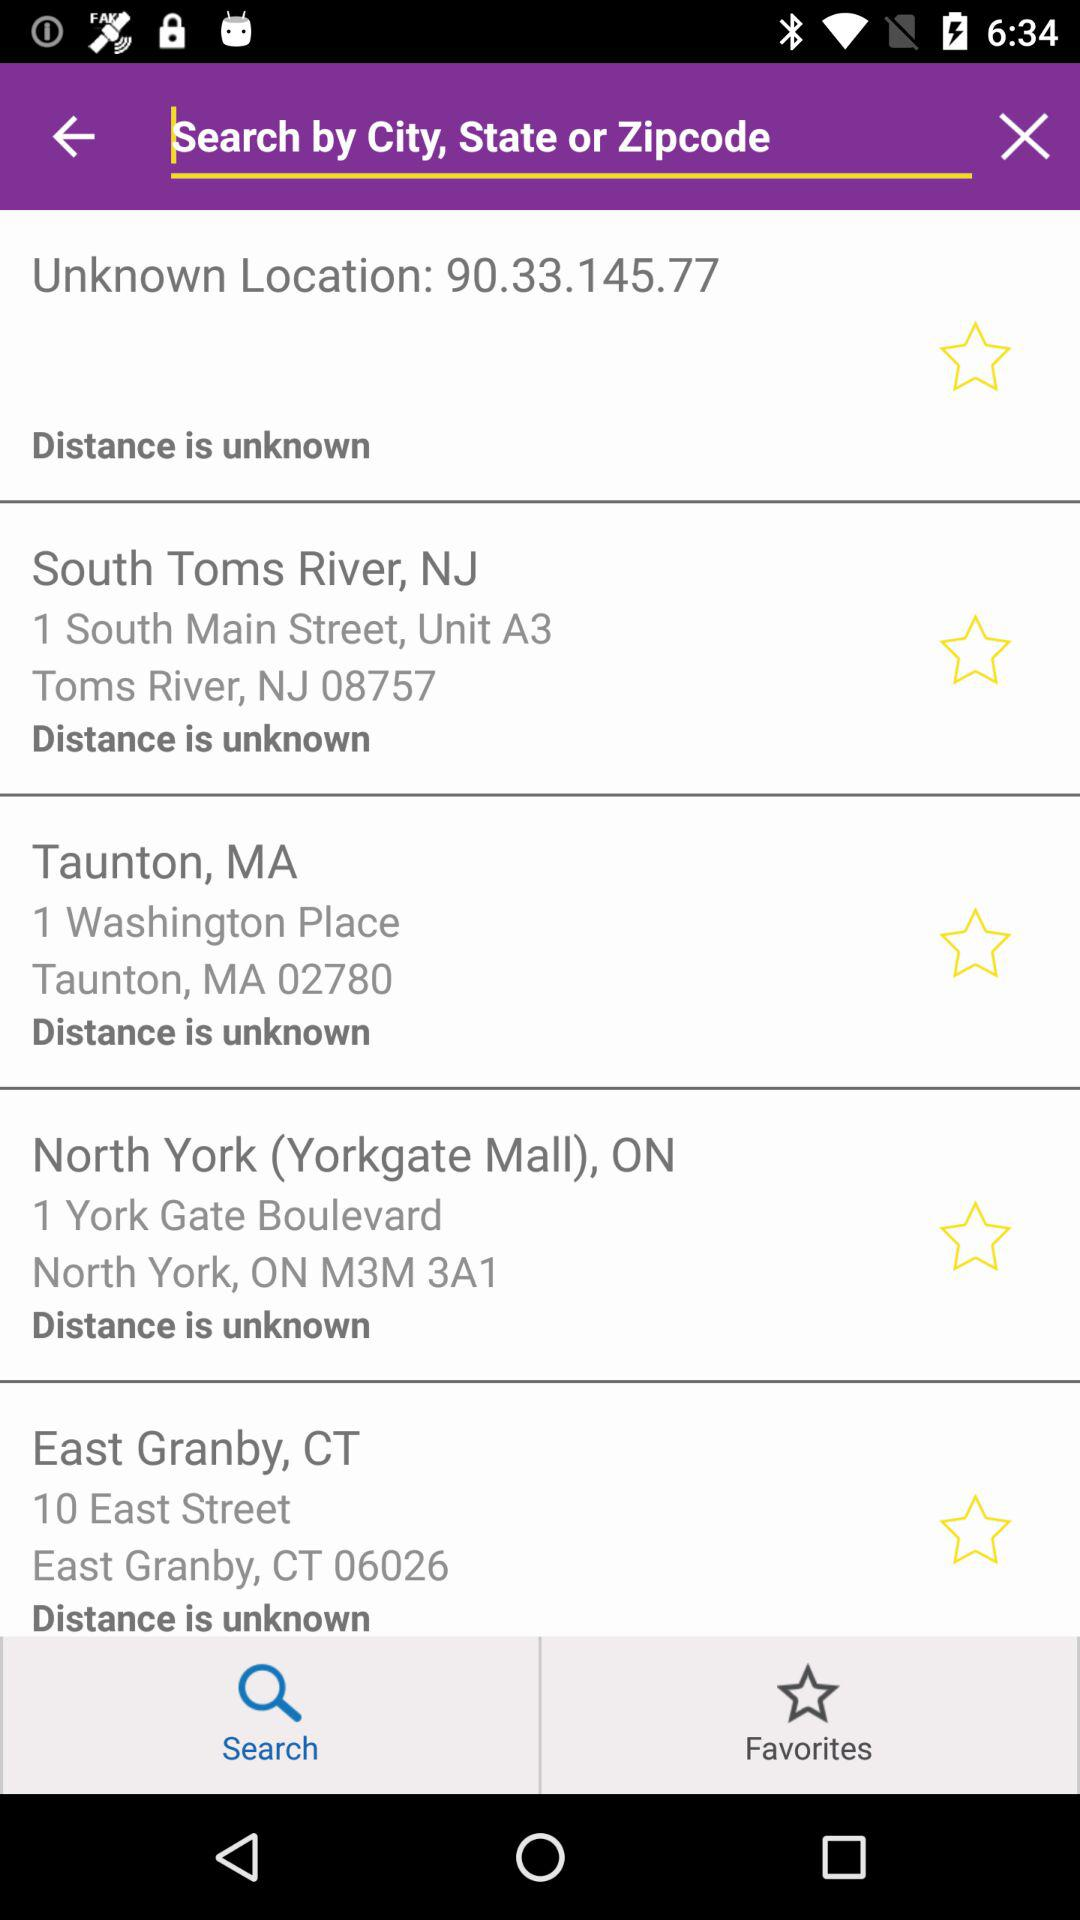What is the Zip code of Taunton, MA? The Zip code is 02780. 